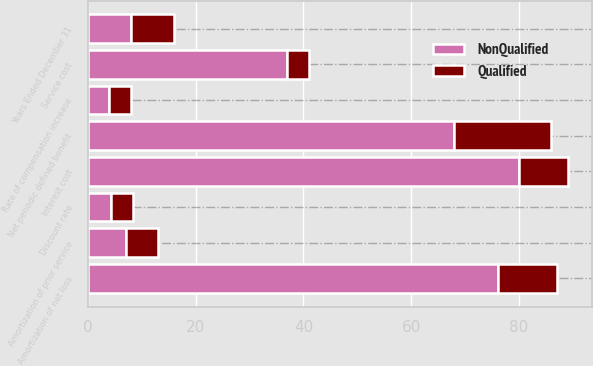<chart> <loc_0><loc_0><loc_500><loc_500><stacked_bar_chart><ecel><fcel>Years Ended December 31<fcel>Service cost<fcel>Interest cost<fcel>Amortization of prior service<fcel>Amortization of net loss<fcel>Net periodic defined benefit<fcel>Discount rate<fcel>Rate of compensation increase<nl><fcel>NonQualified<fcel>8<fcel>37<fcel>80<fcel>7<fcel>76<fcel>68<fcel>4.2<fcel>4<nl><fcel>Qualified<fcel>8<fcel>4<fcel>9<fcel>6<fcel>11<fcel>18<fcel>4.2<fcel>4<nl></chart> 